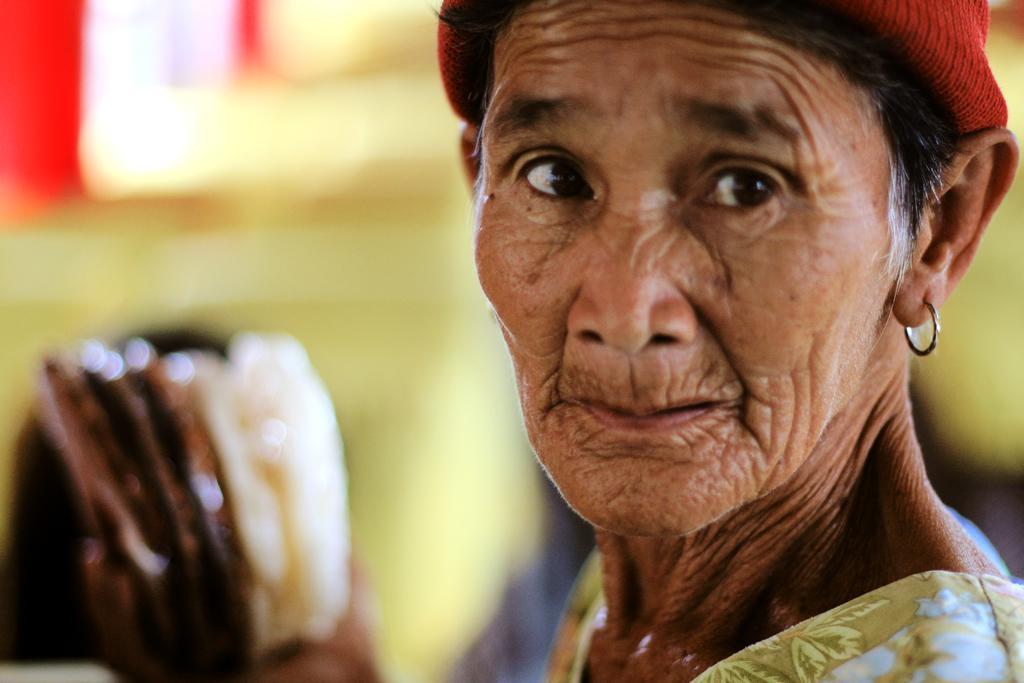Please provide a concise description of this image. In this image there is a woman towards the right of the image, she is wearing a cap, there is an object towards the bottom of the image, the background of the image is blurred. 